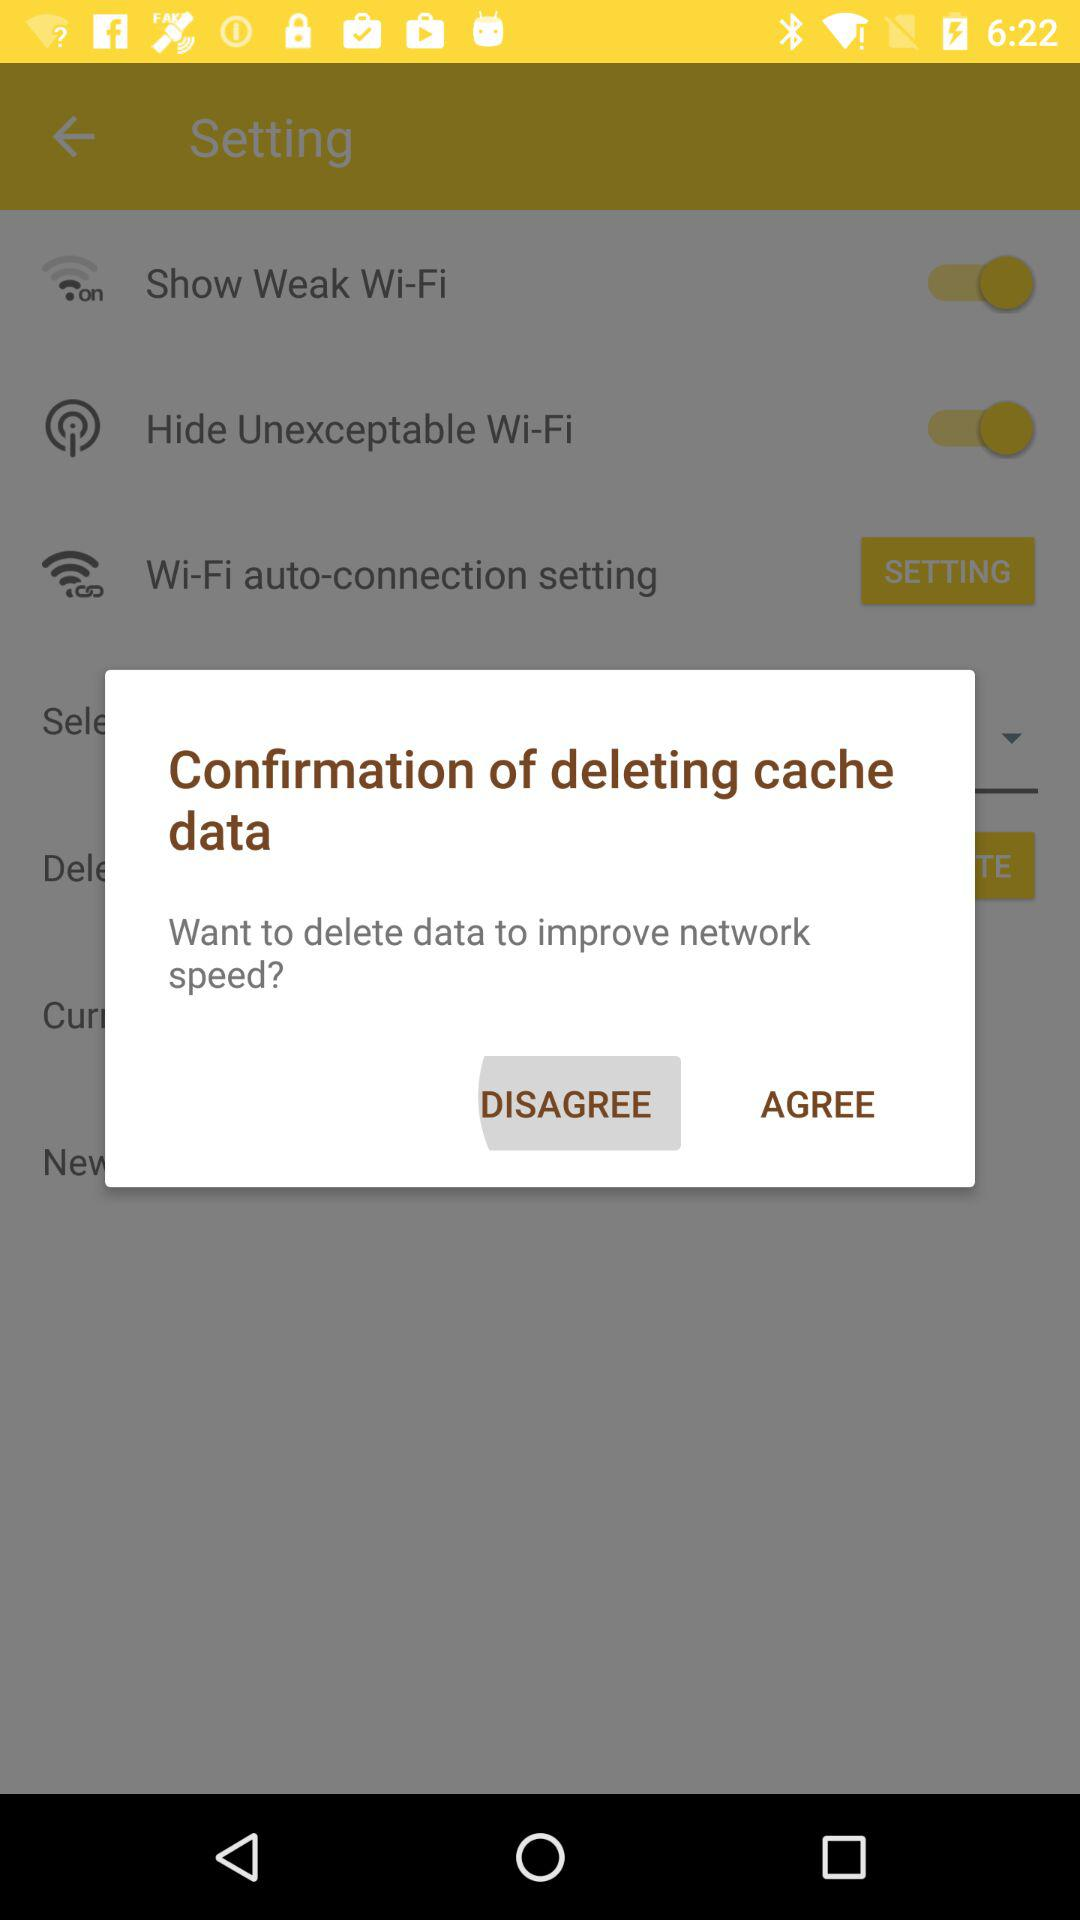Which button is selected? The selected button is "DISAGREE". 